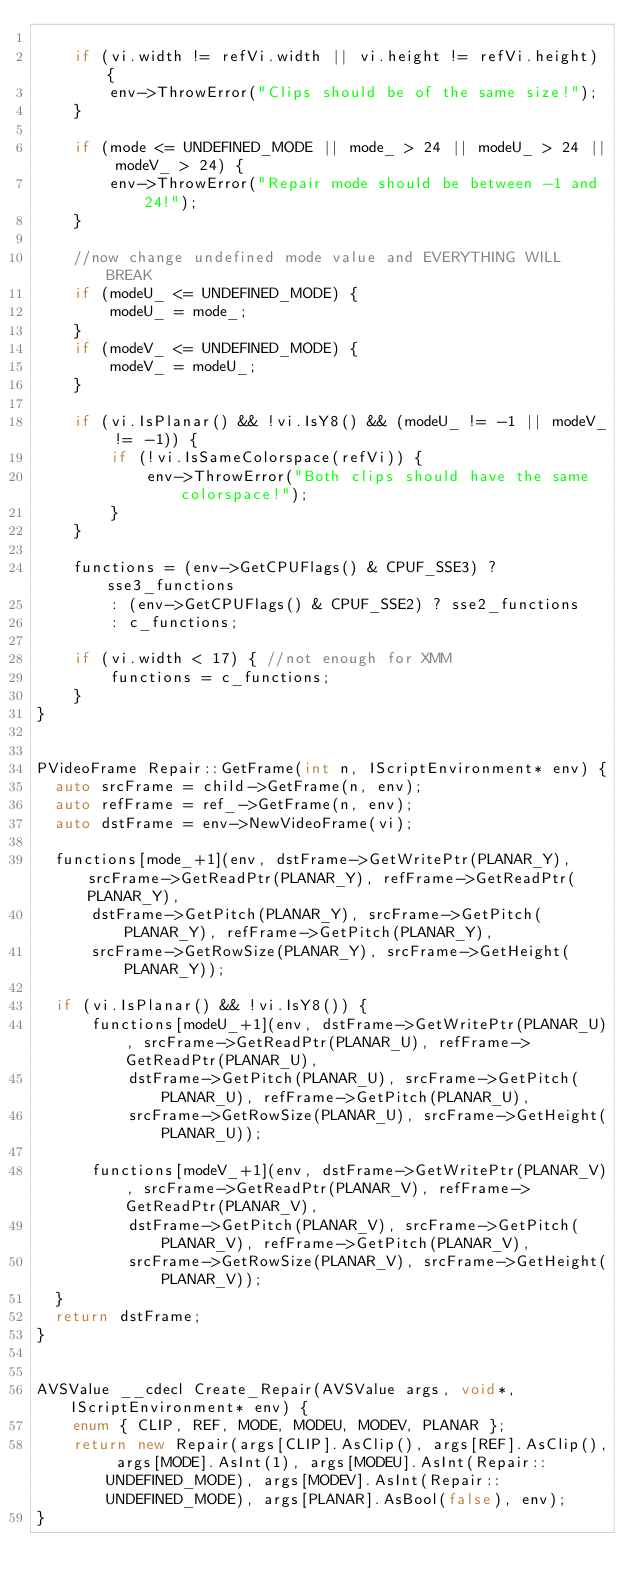<code> <loc_0><loc_0><loc_500><loc_500><_C++_>
    if (vi.width != refVi.width || vi.height != refVi.height) {
        env->ThrowError("Clips should be of the same size!");
    }

    if (mode <= UNDEFINED_MODE || mode_ > 24 || modeU_ > 24 || modeV_ > 24) {
        env->ThrowError("Repair mode should be between -1 and 24!");
    }

    //now change undefined mode value and EVERYTHING WILL BREAK
    if (modeU_ <= UNDEFINED_MODE) { 
        modeU_ = mode_;
    }
    if (modeV_ <= UNDEFINED_MODE) {
        modeV_ = modeU_;
    }

    if (vi.IsPlanar() && !vi.IsY8() && (modeU_ != -1 || modeV_ != -1)) {
        if (!vi.IsSameColorspace(refVi)) {
            env->ThrowError("Both clips should have the same colorspace!");
        }
    }

    functions = (env->GetCPUFlags() & CPUF_SSE3) ? sse3_functions 
        : (env->GetCPUFlags() & CPUF_SSE2) ? sse2_functions
        : c_functions;

    if (vi.width < 17) { //not enough for XMM
        functions = c_functions;
    }
}


PVideoFrame Repair::GetFrame(int n, IScriptEnvironment* env) {
  auto srcFrame = child->GetFrame(n, env);
  auto refFrame = ref_->GetFrame(n, env);
  auto dstFrame = env->NewVideoFrame(vi);

  functions[mode_+1](env, dstFrame->GetWritePtr(PLANAR_Y), srcFrame->GetReadPtr(PLANAR_Y), refFrame->GetReadPtr(PLANAR_Y),
      dstFrame->GetPitch(PLANAR_Y), srcFrame->GetPitch(PLANAR_Y), refFrame->GetPitch(PLANAR_Y),
      srcFrame->GetRowSize(PLANAR_Y), srcFrame->GetHeight(PLANAR_Y));

  if (vi.IsPlanar() && !vi.IsY8()) {
      functions[modeU_+1](env, dstFrame->GetWritePtr(PLANAR_U), srcFrame->GetReadPtr(PLANAR_U), refFrame->GetReadPtr(PLANAR_U),
          dstFrame->GetPitch(PLANAR_U), srcFrame->GetPitch(PLANAR_U), refFrame->GetPitch(PLANAR_U),
          srcFrame->GetRowSize(PLANAR_U), srcFrame->GetHeight(PLANAR_U));

      functions[modeV_+1](env, dstFrame->GetWritePtr(PLANAR_V), srcFrame->GetReadPtr(PLANAR_V), refFrame->GetReadPtr(PLANAR_V),
          dstFrame->GetPitch(PLANAR_V), srcFrame->GetPitch(PLANAR_V), refFrame->GetPitch(PLANAR_V),
          srcFrame->GetRowSize(PLANAR_V), srcFrame->GetHeight(PLANAR_V));
  }
  return dstFrame;
}


AVSValue __cdecl Create_Repair(AVSValue args, void*, IScriptEnvironment* env) {
    enum { CLIP, REF, MODE, MODEU, MODEV, PLANAR };
    return new Repair(args[CLIP].AsClip(), args[REF].AsClip(), args[MODE].AsInt(1), args[MODEU].AsInt(Repair::UNDEFINED_MODE), args[MODEV].AsInt(Repair::UNDEFINED_MODE), args[PLANAR].AsBool(false), env);
}
</code> 